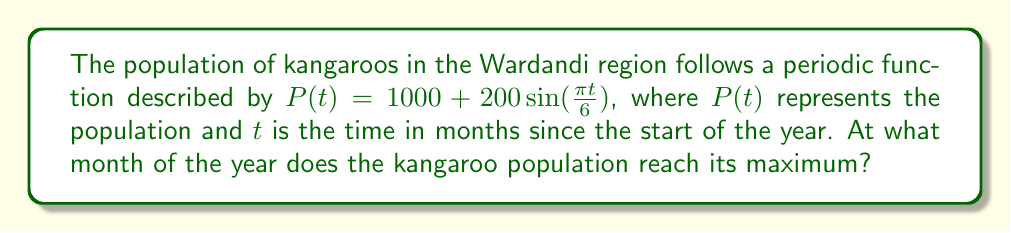Teach me how to tackle this problem. Let's approach this step-by-step:

1) The given function is of the form $a\sin(bt) + c$, where:
   $a = 200$ (amplitude)
   $b = \frac{\pi}{6}$ (angular frequency)
   $c = 1000$ (vertical shift)

2) For a sine function, the maximum occurs when $\sin(bt) = 1$, which happens when $bt = \frac{\pi}{2}$ (or 90 degrees).

3) So, we need to solve the equation:
   $$\frac{\pi t}{6} = \frac{\pi}{2}$$

4) Multiplying both sides by $\frac{6}{\pi}$:
   $$t = 6 \cdot \frac{1}{2} = 3$$

5) This means the population reaches its maximum 3 months after the start of the year.

6) In the Wardandi calendar, the year traditionally starts with the season of Birak (December-January). Counting 3 months from the start of December gives us March.

7) March corresponds to the beginning of the season of Bunuru in the Wardandi calendar, known for its warm, dry weather.
Answer: March (3 months after the start of the year) 